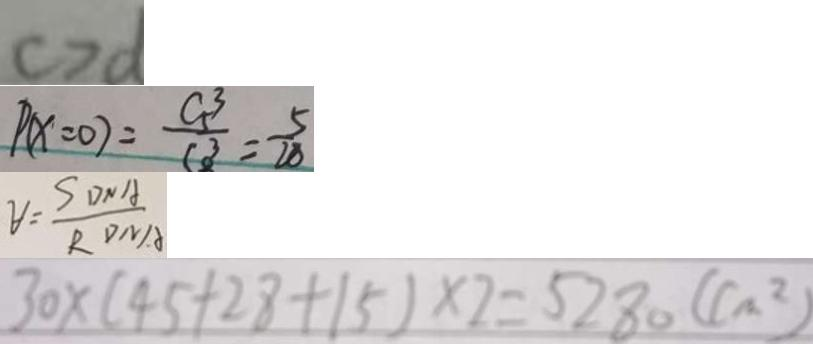<formula> <loc_0><loc_0><loc_500><loc_500>c > d 
 P ( x = 0 ) = \frac { C 5 _ { 1 } ^ { 3 } } { C o ^ { 3 } } = \frac { 5 } { 2 8 } 
 V = \frac { S D N A } { R D M A } 
 3 0 \times ( 4 5 + 2 8 + 1 5 ) \times 2 = 5 2 8 0 ( c m ^ { 2 } )</formula> 